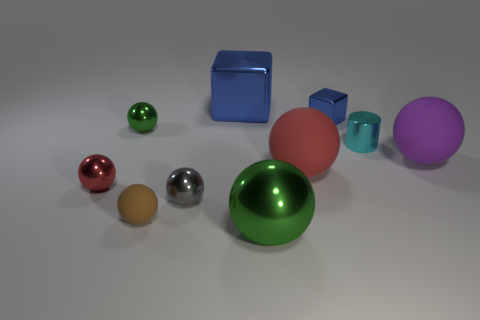There is a tiny rubber object; does it have the same color as the large thing that is on the right side of the cyan metallic cylinder?
Your answer should be compact. No. How many spheres are either yellow objects or small red shiny objects?
Give a very brief answer. 1. The large shiny thing that is in front of the purple ball is what color?
Offer a very short reply. Green. There is a large shiny object that is the same color as the small block; what is its shape?
Provide a succinct answer. Cube. What number of purple balls are the same size as the gray thing?
Your answer should be compact. 0. There is a green thing behind the cyan metallic cylinder; is its shape the same as the cyan thing on the right side of the small green sphere?
Provide a short and direct response. No. There is a red object that is to the right of the green metallic object to the right of the green shiny sphere behind the tiny cylinder; what is its material?
Provide a succinct answer. Rubber. The gray shiny thing that is the same size as the shiny cylinder is what shape?
Give a very brief answer. Sphere. Are there any tiny objects that have the same color as the small cube?
Ensure brevity in your answer.  No. What is the size of the cylinder?
Give a very brief answer. Small. 